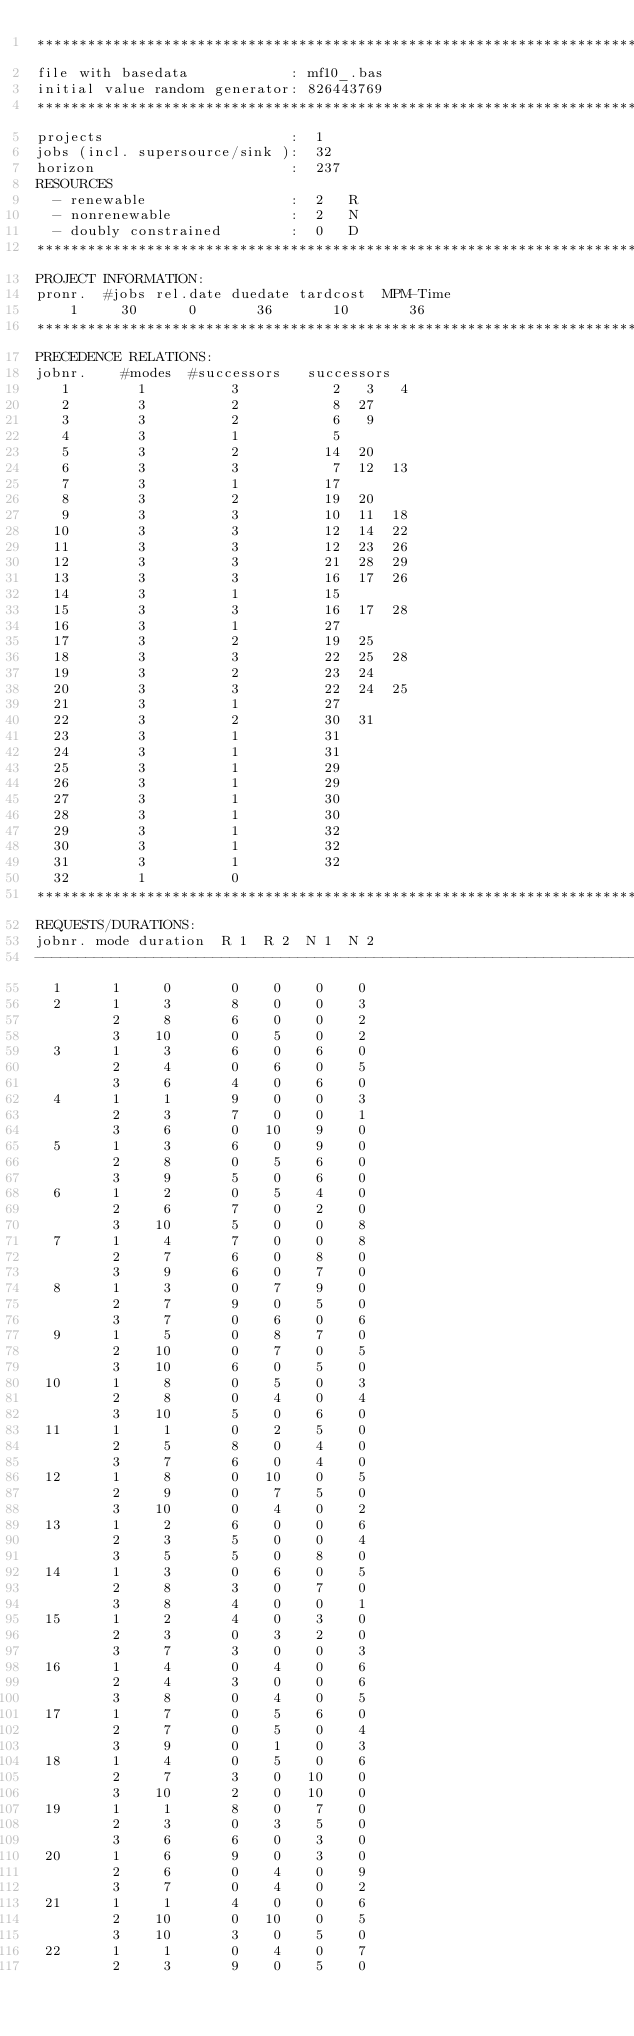<code> <loc_0><loc_0><loc_500><loc_500><_ObjectiveC_>************************************************************************
file with basedata            : mf10_.bas
initial value random generator: 826443769
************************************************************************
projects                      :  1
jobs (incl. supersource/sink ):  32
horizon                       :  237
RESOURCES
  - renewable                 :  2   R
  - nonrenewable              :  2   N
  - doubly constrained        :  0   D
************************************************************************
PROJECT INFORMATION:
pronr.  #jobs rel.date duedate tardcost  MPM-Time
    1     30      0       36       10       36
************************************************************************
PRECEDENCE RELATIONS:
jobnr.    #modes  #successors   successors
   1        1          3           2   3   4
   2        3          2           8  27
   3        3          2           6   9
   4        3          1           5
   5        3          2          14  20
   6        3          3           7  12  13
   7        3          1          17
   8        3          2          19  20
   9        3          3          10  11  18
  10        3          3          12  14  22
  11        3          3          12  23  26
  12        3          3          21  28  29
  13        3          3          16  17  26
  14        3          1          15
  15        3          3          16  17  28
  16        3          1          27
  17        3          2          19  25
  18        3          3          22  25  28
  19        3          2          23  24
  20        3          3          22  24  25
  21        3          1          27
  22        3          2          30  31
  23        3          1          31
  24        3          1          31
  25        3          1          29
  26        3          1          29
  27        3          1          30
  28        3          1          30
  29        3          1          32
  30        3          1          32
  31        3          1          32
  32        1          0        
************************************************************************
REQUESTS/DURATIONS:
jobnr. mode duration  R 1  R 2  N 1  N 2
------------------------------------------------------------------------
  1      1     0       0    0    0    0
  2      1     3       8    0    0    3
         2     8       6    0    0    2
         3    10       0    5    0    2
  3      1     3       6    0    6    0
         2     4       0    6    0    5
         3     6       4    0    6    0
  4      1     1       9    0    0    3
         2     3       7    0    0    1
         3     6       0   10    9    0
  5      1     3       6    0    9    0
         2     8       0    5    6    0
         3     9       5    0    6    0
  6      1     2       0    5    4    0
         2     6       7    0    2    0
         3    10       5    0    0    8
  7      1     4       7    0    0    8
         2     7       6    0    8    0
         3     9       6    0    7    0
  8      1     3       0    7    9    0
         2     7       9    0    5    0
         3     7       0    6    0    6
  9      1     5       0    8    7    0
         2    10       0    7    0    5
         3    10       6    0    5    0
 10      1     8       0    5    0    3
         2     8       0    4    0    4
         3    10       5    0    6    0
 11      1     1       0    2    5    0
         2     5       8    0    4    0
         3     7       6    0    4    0
 12      1     8       0   10    0    5
         2     9       0    7    5    0
         3    10       0    4    0    2
 13      1     2       6    0    0    6
         2     3       5    0    0    4
         3     5       5    0    8    0
 14      1     3       0    6    0    5
         2     8       3    0    7    0
         3     8       4    0    0    1
 15      1     2       4    0    3    0
         2     3       0    3    2    0
         3     7       3    0    0    3
 16      1     4       0    4    0    6
         2     4       3    0    0    6
         3     8       0    4    0    5
 17      1     7       0    5    6    0
         2     7       0    5    0    4
         3     9       0    1    0    3
 18      1     4       0    5    0    6
         2     7       3    0   10    0
         3    10       2    0   10    0
 19      1     1       8    0    7    0
         2     3       0    3    5    0
         3     6       6    0    3    0
 20      1     6       9    0    3    0
         2     6       0    4    0    9
         3     7       0    4    0    2
 21      1     1       4    0    0    6
         2    10       0   10    0    5
         3    10       3    0    5    0
 22      1     1       0    4    0    7
         2     3       9    0    5    0</code> 